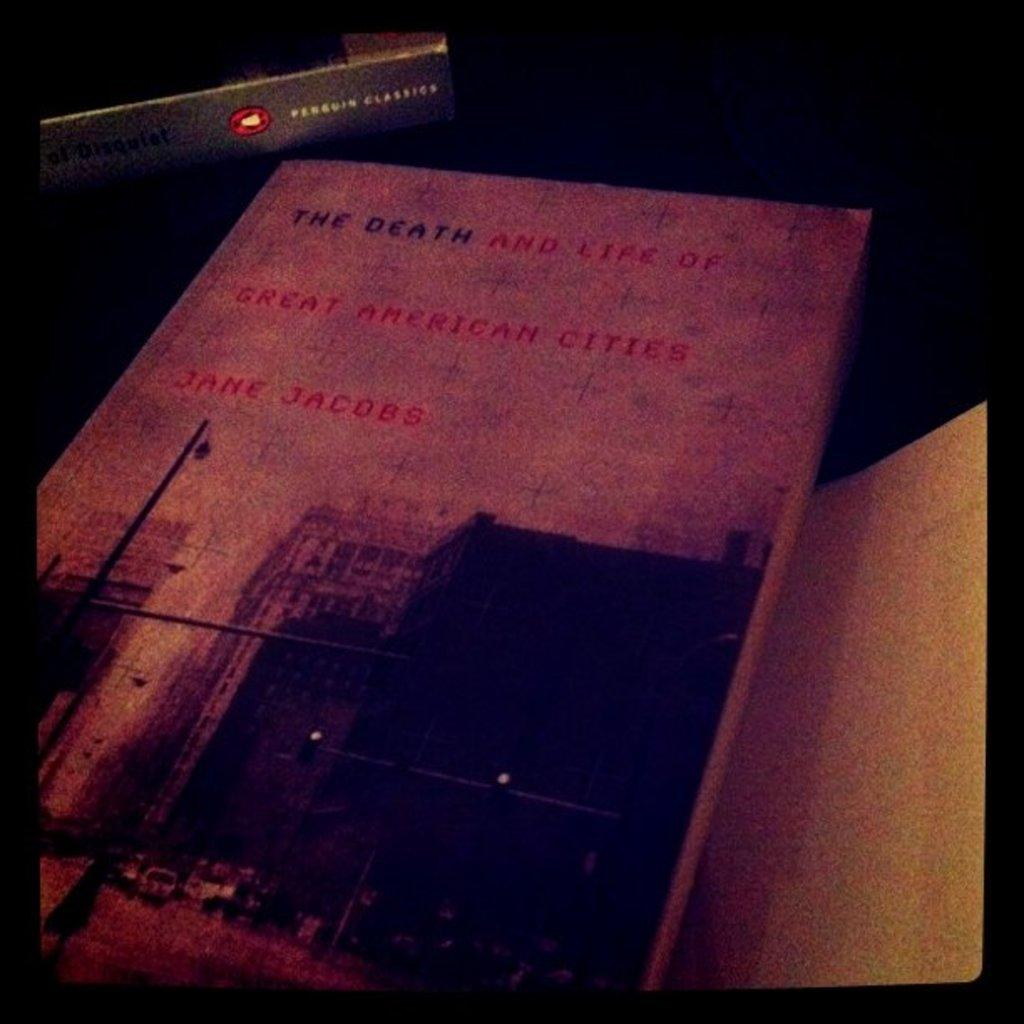<image>
Offer a succinct explanation of the picture presented. a book called the death and life of great american cities by jane jacobs 